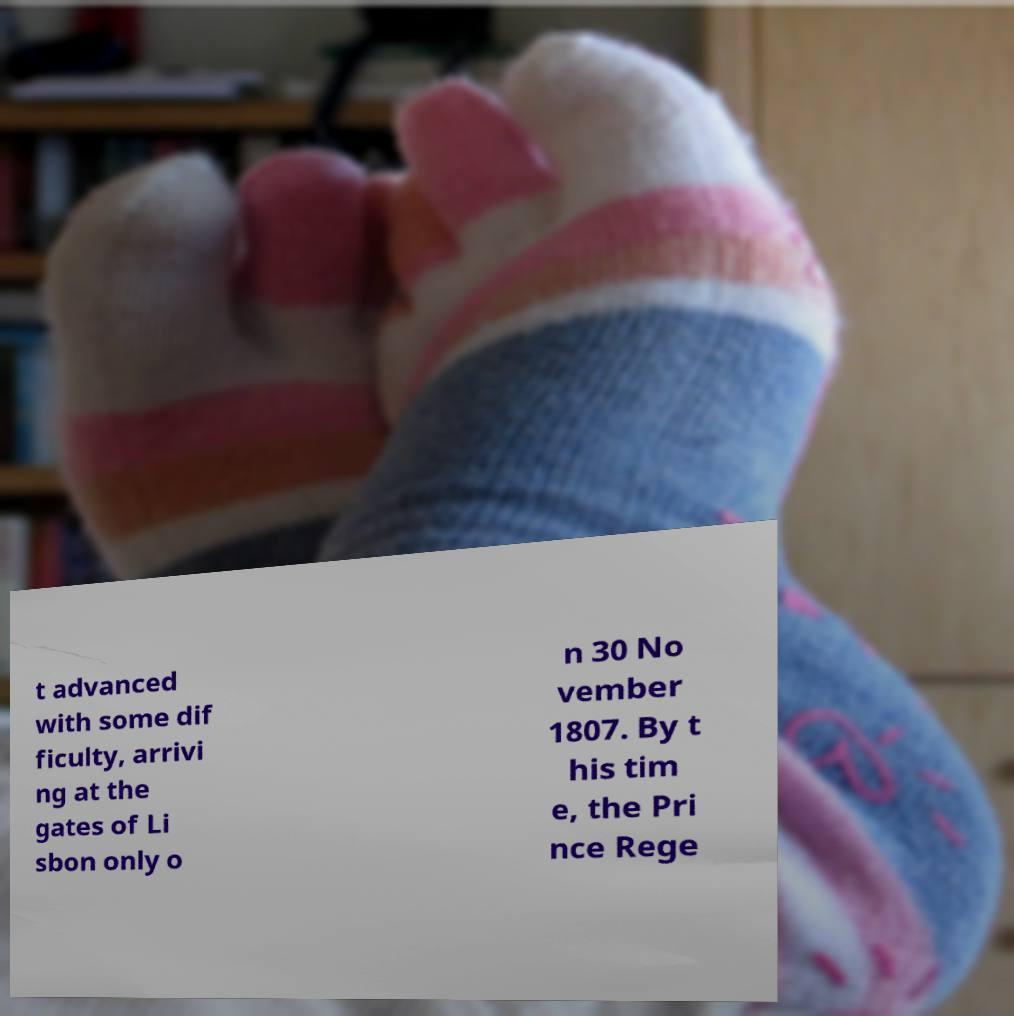Please identify and transcribe the text found in this image. t advanced with some dif ficulty, arrivi ng at the gates of Li sbon only o n 30 No vember 1807. By t his tim e, the Pri nce Rege 